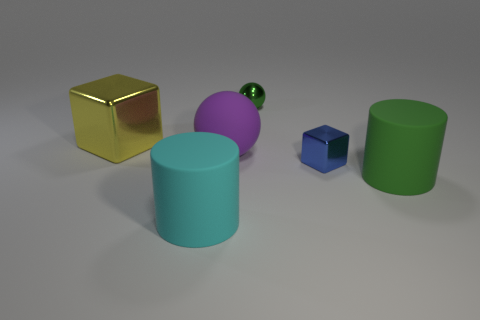Are there any big shiny things of the same shape as the green matte thing?
Keep it short and to the point. No. The shiny object that is left of the small blue shiny block and in front of the tiny green metallic object has what shape?
Offer a terse response. Cube. There is a matte cylinder to the left of the big green cylinder; what is its size?
Make the answer very short. Large. Do the blue cube and the green metal object have the same size?
Keep it short and to the point. Yes. Is the number of matte cylinders on the left side of the purple ball less than the number of big yellow objects that are to the left of the small green sphere?
Your answer should be very brief. No. There is a object that is both in front of the big yellow metallic thing and left of the large purple rubber sphere; what size is it?
Your answer should be compact. Large. Is there a large green rubber object in front of the metal cube that is left of the metallic block right of the tiny green ball?
Offer a terse response. Yes. Are there any green rubber cylinders?
Your answer should be very brief. Yes. Are there more big purple things that are on the left side of the big sphere than blue blocks on the left side of the green shiny object?
Keep it short and to the point. No. There is a green object that is made of the same material as the large cyan cylinder; what is its size?
Offer a very short reply. Large. 